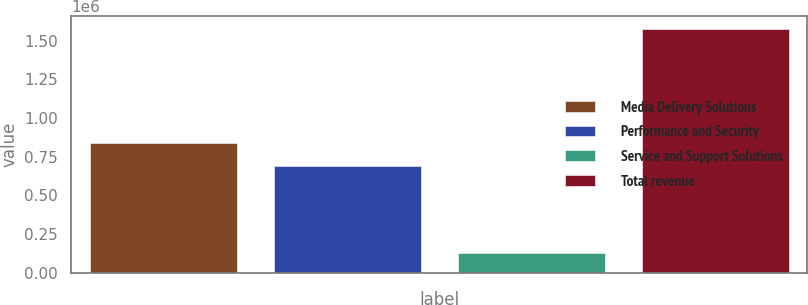<chart> <loc_0><loc_0><loc_500><loc_500><bar_chart><fcel>Media Delivery Solutions<fcel>Performance and Security<fcel>Service and Support Solutions<fcel>Total revenue<nl><fcel>835542<fcel>690559<fcel>128087<fcel>1.57792e+06<nl></chart> 